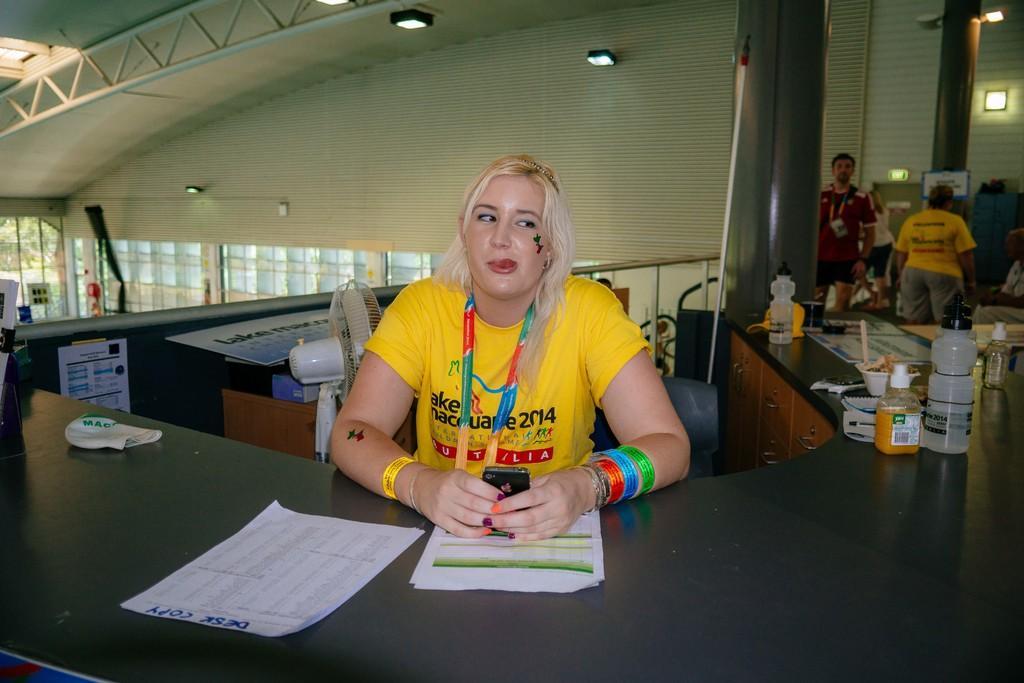How would you summarize this image in a sentence or two? In this image I can see a table among them this woman is holding some object in hands. Here I can see papers, bottles and other objects on a table. In the background I can see a fan, lights and pillars. 